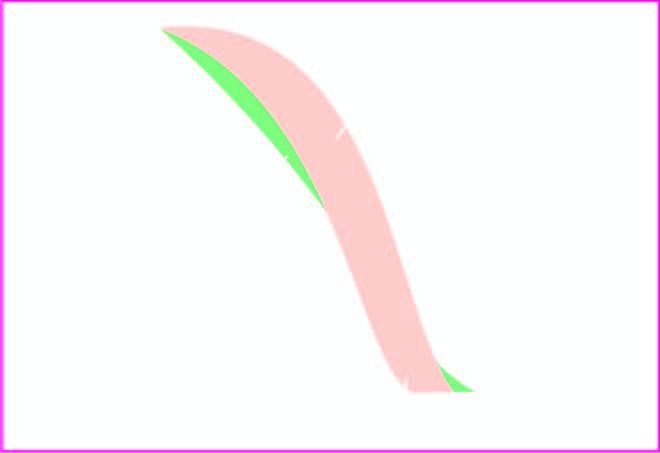did the surrounding zone decrease fragility?
Answer the question using a single word or phrase. No 